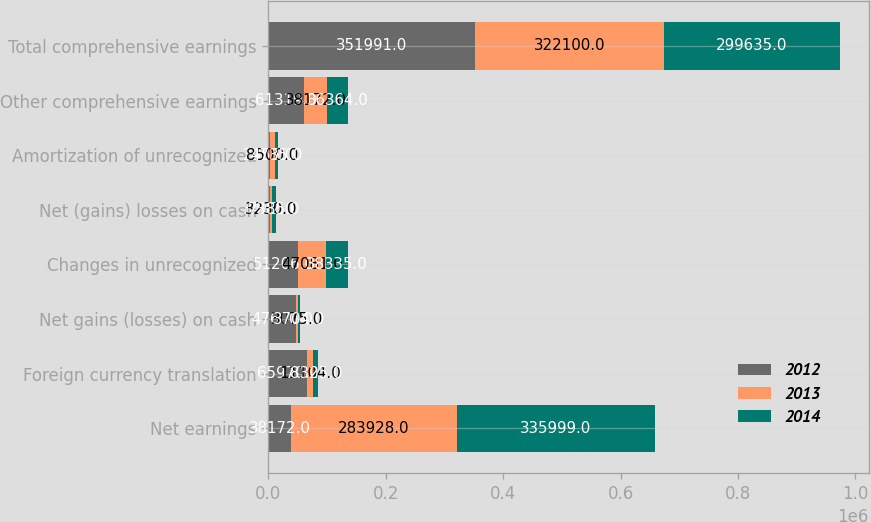Convert chart to OTSL. <chart><loc_0><loc_0><loc_500><loc_500><stacked_bar_chart><ecel><fcel>Net earnings<fcel>Foreign currency translation<fcel>Net gains (losses) on cash<fcel>Changes in unrecognized<fcel>Net (gains) losses on cash<fcel>Amortization of unrecognized<fcel>Other comprehensive earnings<fcel>Total comprehensive earnings<nl><fcel>2012<fcel>38172<fcel>65970<fcel>47600<fcel>51206<fcel>3402<fcel>2955<fcel>61319<fcel>351991<nl><fcel>2013<fcel>283928<fcel>11104<fcel>3075<fcel>47081<fcel>3230<fcel>8500<fcel>38172<fcel>322100<nl><fcel>2014<fcel>335999<fcel>8325<fcel>3704<fcel>38335<fcel>7385<fcel>4735<fcel>36364<fcel>299635<nl></chart> 